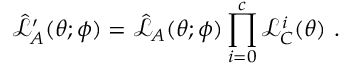<formula> <loc_0><loc_0><loc_500><loc_500>\hat { \mathcal { L } } _ { A } ^ { \prime } ( \theta ; \phi ) = \hat { \mathcal { L } } _ { A } ( \theta ; \phi ) \prod _ { i = 0 } ^ { c } \mathcal { L } _ { C } ^ { i } ( \theta ) .</formula> 